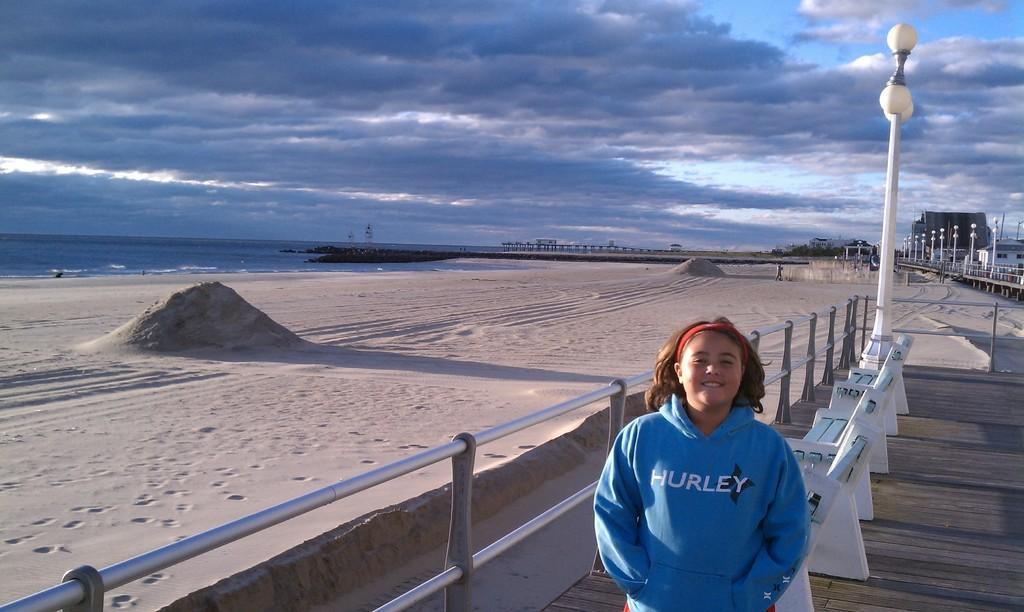Can you describe this image briefly? This image consists of a girl wearing a blue jacket. In the background, we can see the benches and a pole along with the lamps. On the left, there is an ocean and we can see the sand. At the top, there are clouds in the sky. Beside the girl there is a railing. 